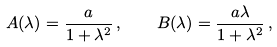<formula> <loc_0><loc_0><loc_500><loc_500>A ( \lambda ) = \frac { a } { 1 + \lambda ^ { 2 } } \, , \quad B ( \lambda ) = \frac { a \lambda } { 1 + \lambda ^ { 2 } } \, ,</formula> 